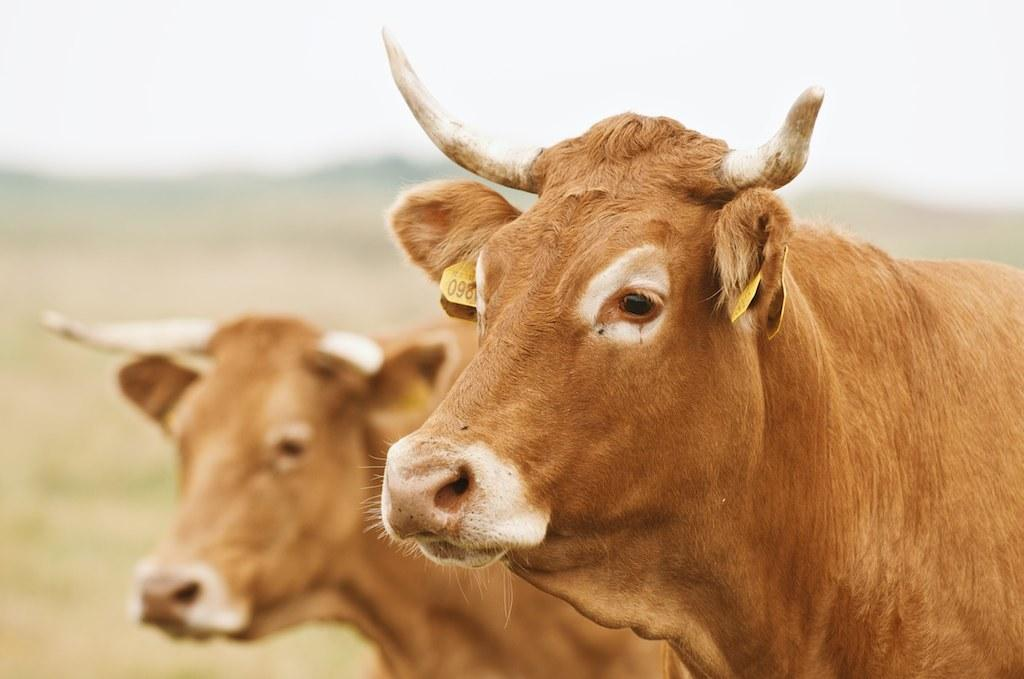How many cows are present in the image? There are two cows in the image. What can be observed in the background of the image? The background of the image is blurred. What type of breakfast is being served in the hospital depicted in the image? There is no hospital or breakfast present in the image; it features two cows with a blurred background. Is there a gate visible in the image? There is no gate present in the image; it features two cows with a blurred background. 